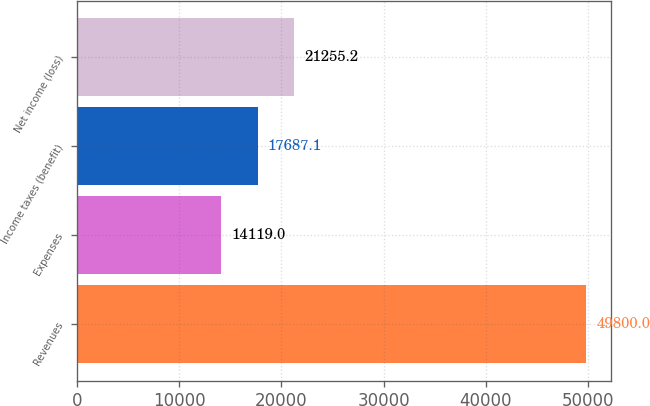<chart> <loc_0><loc_0><loc_500><loc_500><bar_chart><fcel>Revenues<fcel>Expenses<fcel>Income taxes (benefit)<fcel>Net income (loss)<nl><fcel>49800<fcel>14119<fcel>17687.1<fcel>21255.2<nl></chart> 